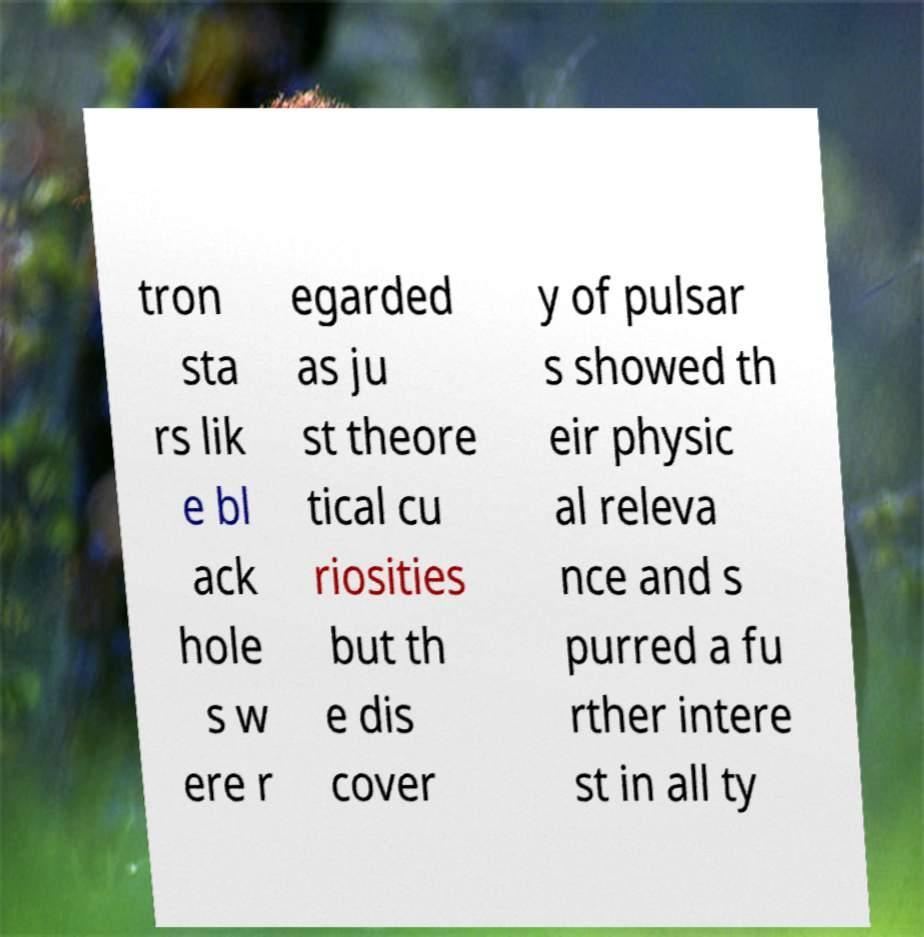Please identify and transcribe the text found in this image. tron sta rs lik e bl ack hole s w ere r egarded as ju st theore tical cu riosities but th e dis cover y of pulsar s showed th eir physic al releva nce and s purred a fu rther intere st in all ty 